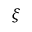<formula> <loc_0><loc_0><loc_500><loc_500>\xi</formula> 